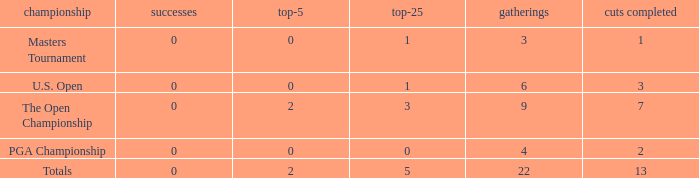How many total cuts were made in events with more than 0 wins and exactly 0 top-5s? 0.0. 